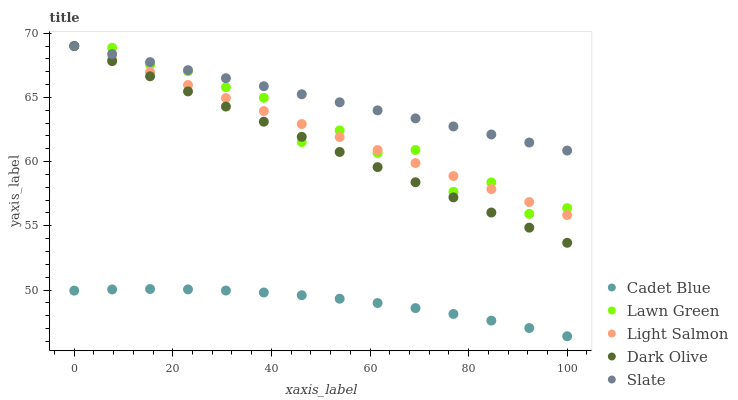Does Cadet Blue have the minimum area under the curve?
Answer yes or no. Yes. Does Slate have the maximum area under the curve?
Answer yes or no. Yes. Does Lawn Green have the minimum area under the curve?
Answer yes or no. No. Does Lawn Green have the maximum area under the curve?
Answer yes or no. No. Is Light Salmon the smoothest?
Answer yes or no. Yes. Is Lawn Green the roughest?
Answer yes or no. Yes. Is Lawn Green the smoothest?
Answer yes or no. No. Is Light Salmon the roughest?
Answer yes or no. No. Does Cadet Blue have the lowest value?
Answer yes or no. Yes. Does Lawn Green have the lowest value?
Answer yes or no. No. Does Slate have the highest value?
Answer yes or no. Yes. Does Cadet Blue have the highest value?
Answer yes or no. No. Is Cadet Blue less than Lawn Green?
Answer yes or no. Yes. Is Lawn Green greater than Cadet Blue?
Answer yes or no. Yes. Does Lawn Green intersect Slate?
Answer yes or no. Yes. Is Lawn Green less than Slate?
Answer yes or no. No. Is Lawn Green greater than Slate?
Answer yes or no. No. Does Cadet Blue intersect Lawn Green?
Answer yes or no. No. 